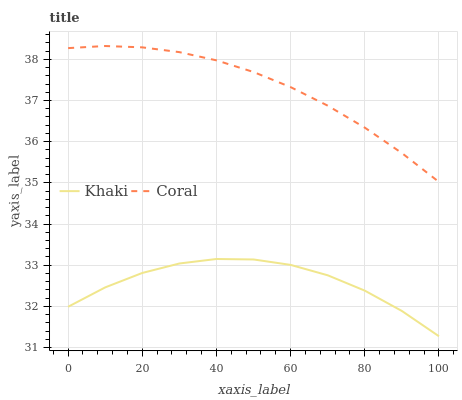Does Khaki have the minimum area under the curve?
Answer yes or no. Yes. Does Coral have the maximum area under the curve?
Answer yes or no. Yes. Does Khaki have the maximum area under the curve?
Answer yes or no. No. Is Coral the smoothest?
Answer yes or no. Yes. Is Khaki the roughest?
Answer yes or no. Yes. Is Khaki the smoothest?
Answer yes or no. No. Does Khaki have the lowest value?
Answer yes or no. Yes. Does Coral have the highest value?
Answer yes or no. Yes. Does Khaki have the highest value?
Answer yes or no. No. Is Khaki less than Coral?
Answer yes or no. Yes. Is Coral greater than Khaki?
Answer yes or no. Yes. Does Khaki intersect Coral?
Answer yes or no. No. 